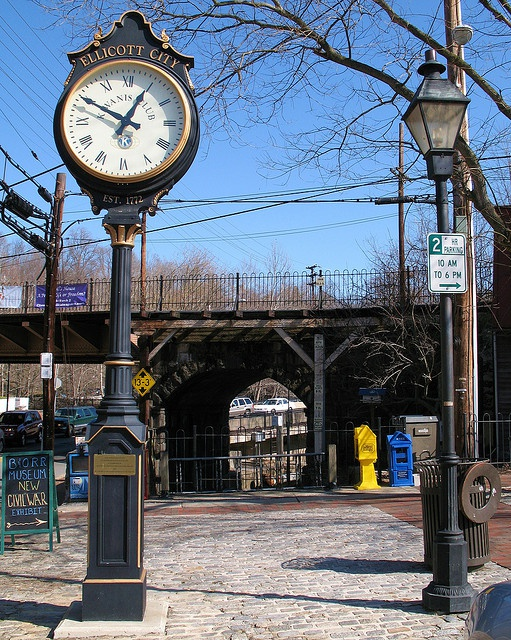Describe the objects in this image and their specific colors. I can see clock in gray, ivory, darkgray, and black tones, car in gray, black, navy, and blue tones, car in gray, black, blue, and darkblue tones, car in gray, white, black, and darkgray tones, and car in gray, lightgray, darkgray, and black tones in this image. 